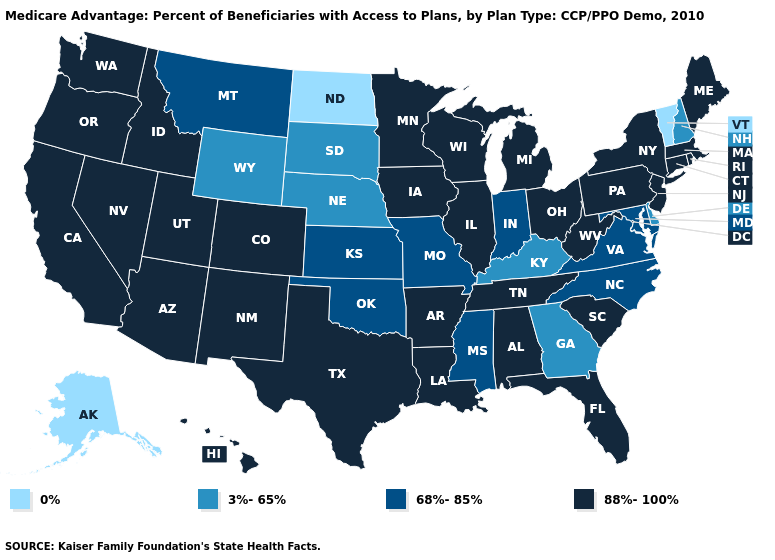Which states have the lowest value in the USA?
Give a very brief answer. Alaska, North Dakota, Vermont. What is the lowest value in the USA?
Be succinct. 0%. What is the highest value in the Northeast ?
Be succinct. 88%-100%. Name the states that have a value in the range 3%-65%?
Keep it brief. Delaware, Georgia, Kentucky, Nebraska, New Hampshire, South Dakota, Wyoming. Among the states that border Iowa , which have the highest value?
Give a very brief answer. Illinois, Minnesota, Wisconsin. Which states have the lowest value in the Northeast?
Short answer required. Vermont. Is the legend a continuous bar?
Short answer required. No. Name the states that have a value in the range 88%-100%?
Give a very brief answer. Alabama, Arkansas, Arizona, California, Colorado, Connecticut, Florida, Hawaii, Iowa, Idaho, Illinois, Louisiana, Massachusetts, Maine, Michigan, Minnesota, New Jersey, New Mexico, Nevada, New York, Ohio, Oregon, Pennsylvania, Rhode Island, South Carolina, Tennessee, Texas, Utah, Washington, Wisconsin, West Virginia. Among the states that border Nebraska , does Missouri have the lowest value?
Concise answer only. No. Does Maine have the lowest value in the Northeast?
Be succinct. No. Name the states that have a value in the range 3%-65%?
Concise answer only. Delaware, Georgia, Kentucky, Nebraska, New Hampshire, South Dakota, Wyoming. Name the states that have a value in the range 0%?
Keep it brief. Alaska, North Dakota, Vermont. Does Vermont have the lowest value in the USA?
Give a very brief answer. Yes. What is the lowest value in the Northeast?
Keep it brief. 0%. 